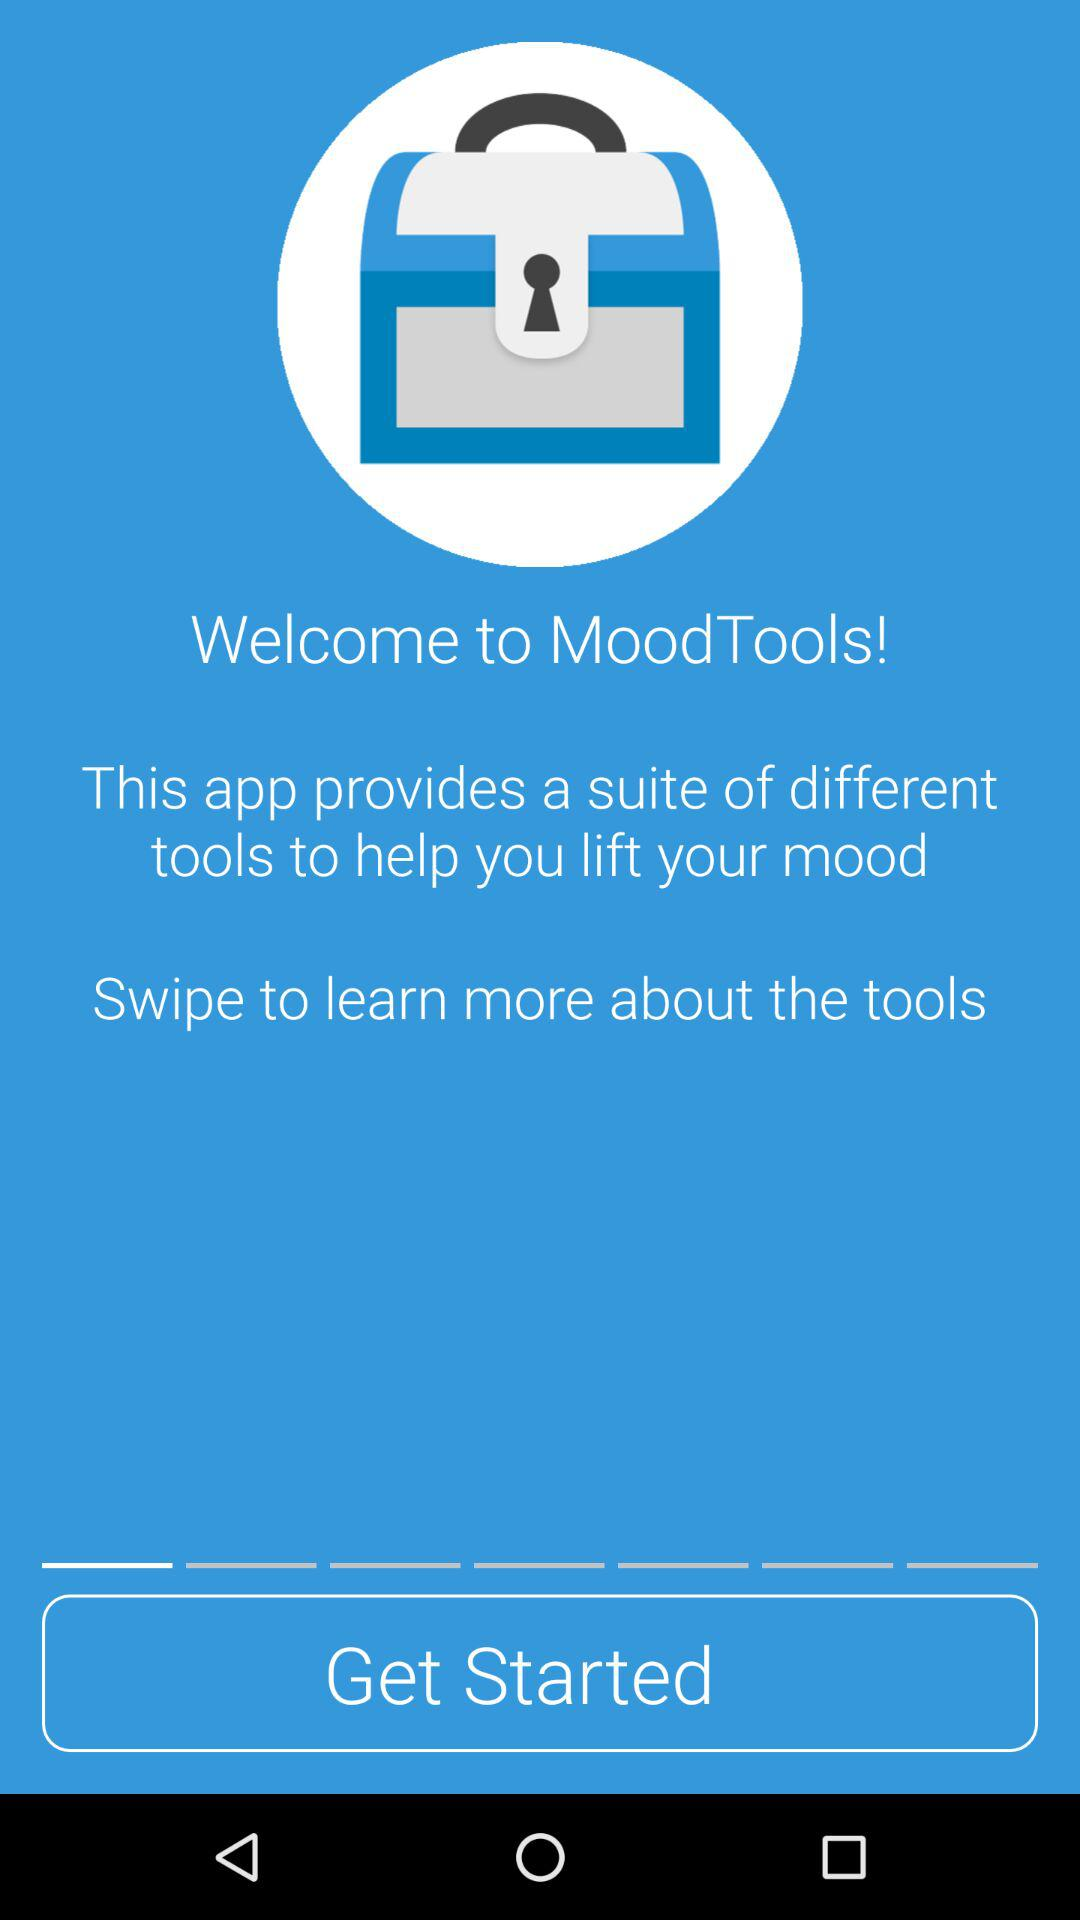What is the name of the app? The name of the app is "MoodTools". 